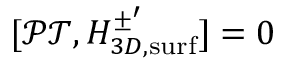<formula> <loc_0><loc_0><loc_500><loc_500>[ \mathcal { P T } , H _ { 3 D , s u r f } ^ { \pm ^ { \prime } } ] = 0</formula> 